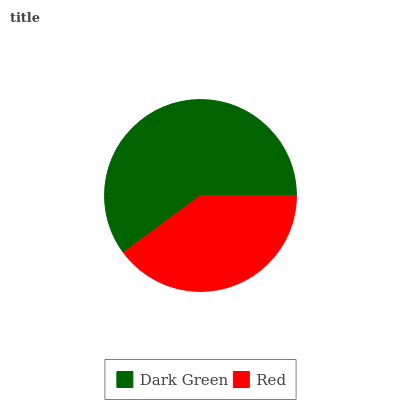Is Red the minimum?
Answer yes or no. Yes. Is Dark Green the maximum?
Answer yes or no. Yes. Is Red the maximum?
Answer yes or no. No. Is Dark Green greater than Red?
Answer yes or no. Yes. Is Red less than Dark Green?
Answer yes or no. Yes. Is Red greater than Dark Green?
Answer yes or no. No. Is Dark Green less than Red?
Answer yes or no. No. Is Dark Green the high median?
Answer yes or no. Yes. Is Red the low median?
Answer yes or no. Yes. Is Red the high median?
Answer yes or no. No. Is Dark Green the low median?
Answer yes or no. No. 